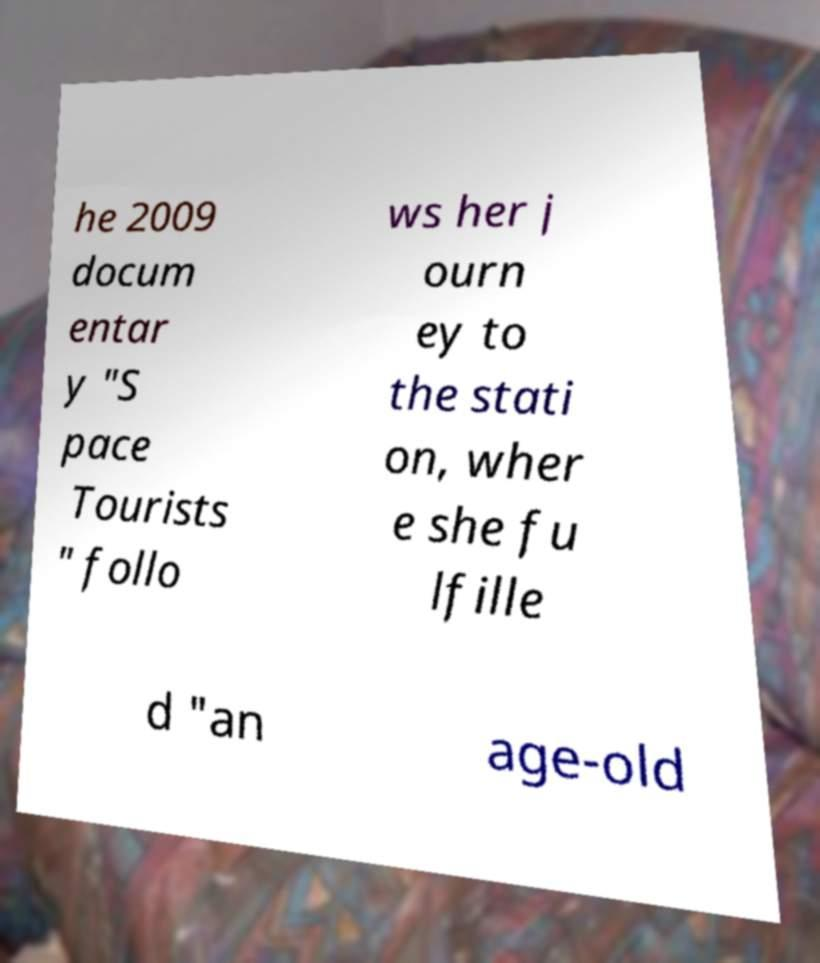I need the written content from this picture converted into text. Can you do that? he 2009 docum entar y "S pace Tourists " follo ws her j ourn ey to the stati on, wher e she fu lfille d "an age-old 